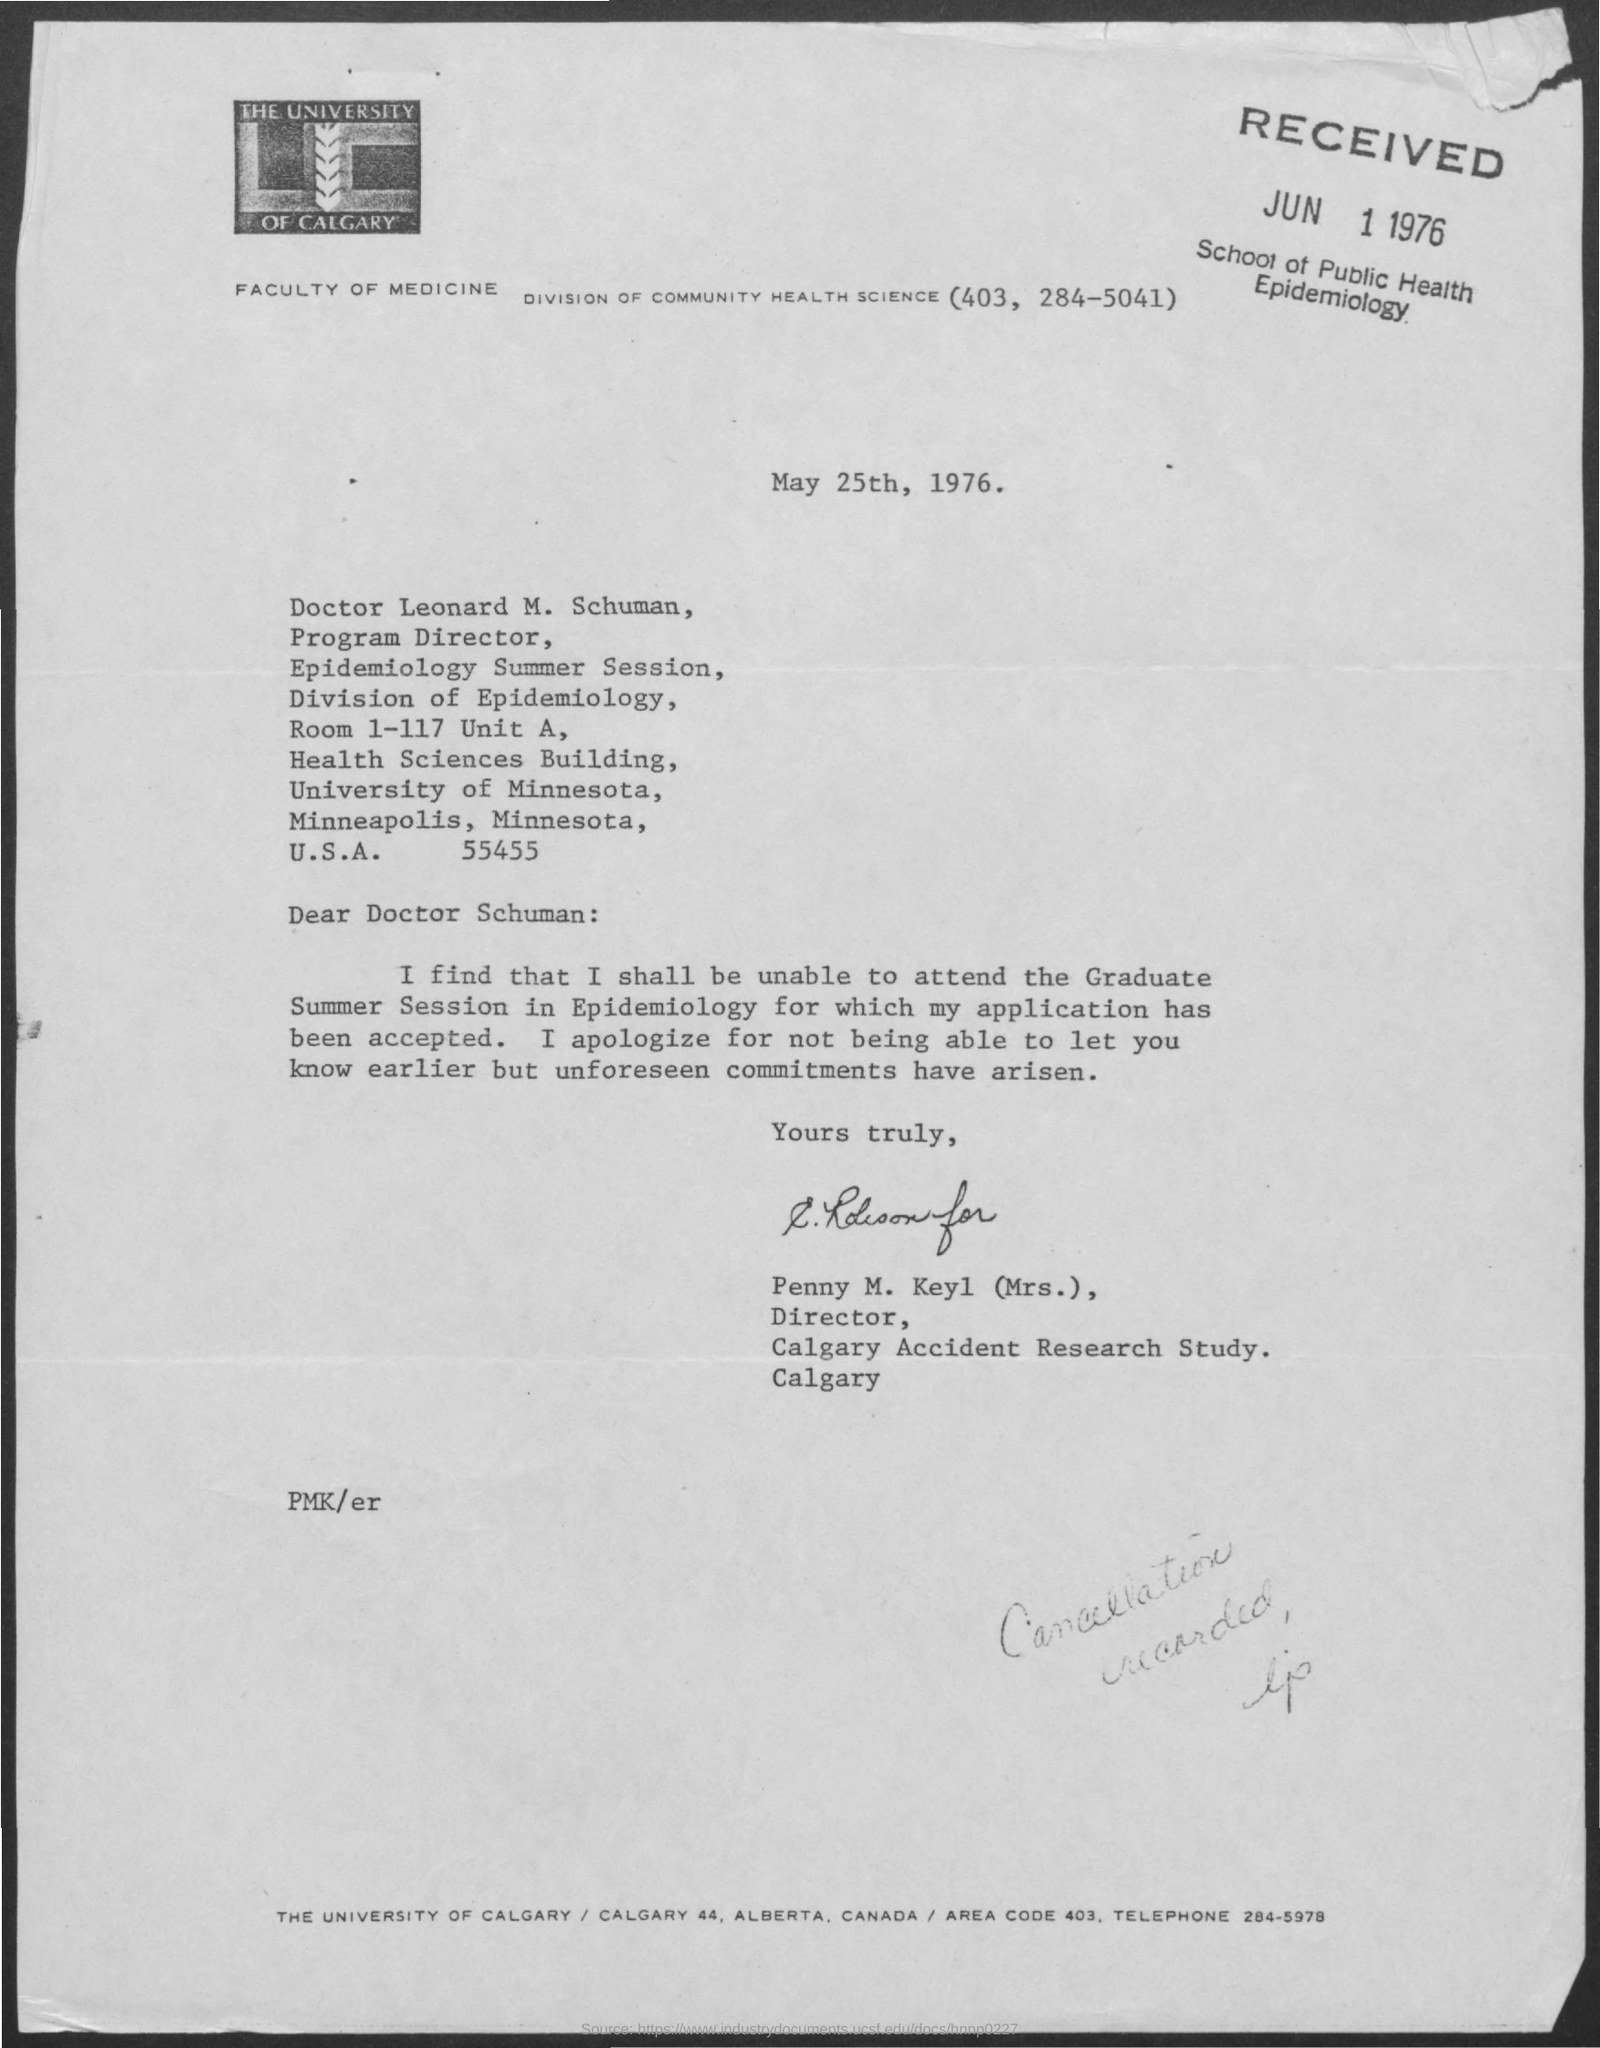Which University is mentioned in the letter head?
Give a very brief answer. THE UNIVERSITY OF CALGARY. Who is the sender of this letter?
Your answer should be compact. Penny M. Keyl (Mrs.). What is the issued date of this letter?
Provide a succinct answer. May 25th, 1976. 